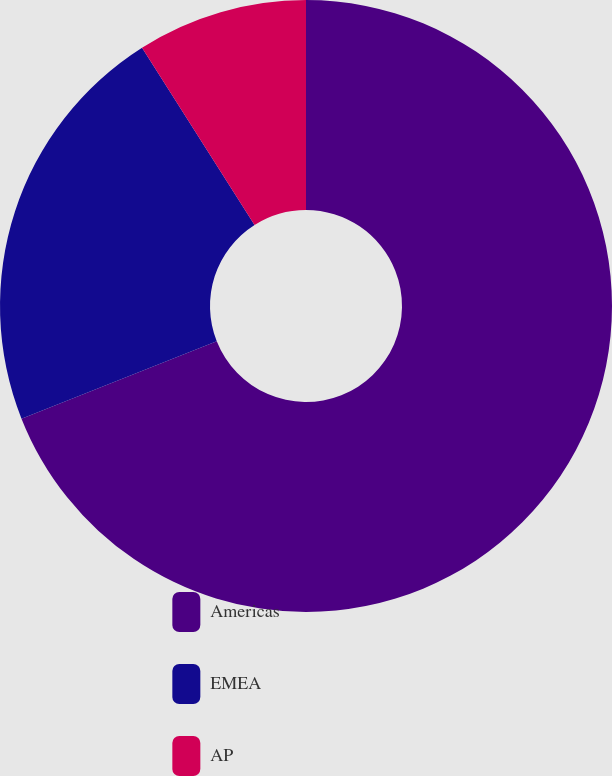Convert chart. <chart><loc_0><loc_0><loc_500><loc_500><pie_chart><fcel>Americas<fcel>EMEA<fcel>AP<nl><fcel>69.0%<fcel>22.0%<fcel>9.0%<nl></chart> 